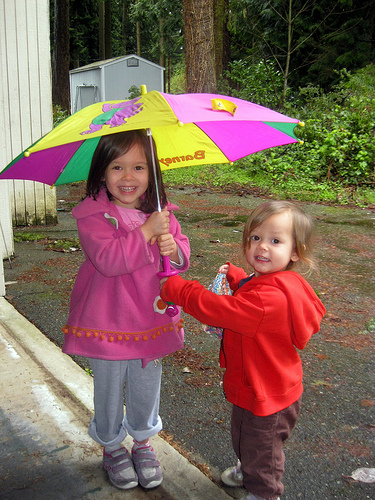What are the children doing? The children appear to be smiling and posing for the photo while sharing an umbrella. Do they look like they are enjoying the day despite the weather? Yes, their expressions suggest they are having a good time, regardless of the overcast weather. 